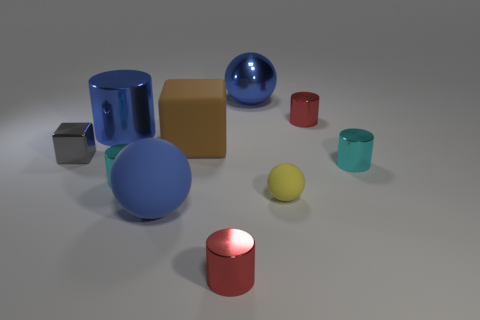Does the big metal ball have the same color as the big rubber ball?
Ensure brevity in your answer.  Yes. Is there a cyan metal cylinder of the same size as the blue cylinder?
Provide a succinct answer. No. Do the small gray thing and the large cylinder have the same material?
Make the answer very short. Yes. How many objects are either yellow things or blue rubber things?
Your answer should be very brief. 2. The gray metallic object has what size?
Your answer should be compact. Small. Is the number of tiny rubber things less than the number of tiny yellow cylinders?
Your answer should be compact. No. How many big objects are the same color as the large matte cube?
Ensure brevity in your answer.  0. Do the ball that is behind the big block and the large cylinder have the same color?
Your answer should be compact. Yes. What shape is the blue thing that is in front of the big metal cylinder?
Give a very brief answer. Sphere. Are there any blue objects that are behind the cyan thing that is to the right of the blue matte thing?
Provide a succinct answer. Yes. 